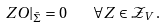<formula> <loc_0><loc_0><loc_500><loc_500>Z O | _ { \bar { \Sigma } } = 0 \quad \forall Z \in \mathcal { Z } _ { V } \, .</formula> 